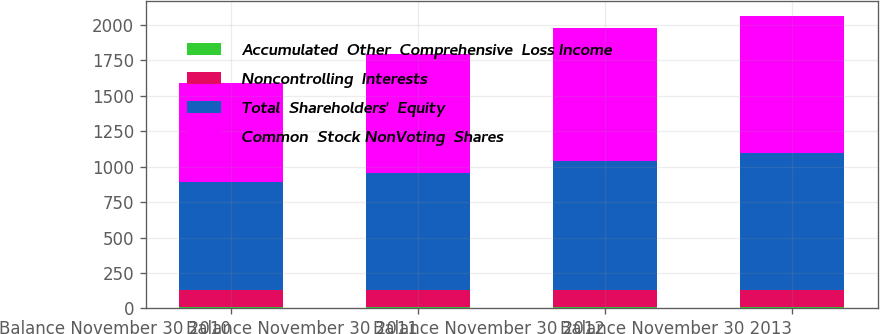<chart> <loc_0><loc_0><loc_500><loc_500><stacked_bar_chart><ecel><fcel>Balance November 30 2010<fcel>Balance November 30 2011<fcel>Balance November 30 2012<fcel>Balance November 30 2013<nl><fcel>Accumulated  Other  Comprehensive  Loss Income<fcel>12.5<fcel>12.4<fcel>12.4<fcel>12.1<nl><fcel>Noncontrolling  Interests<fcel>120.6<fcel>120.5<fcel>120.1<fcel>119<nl><fcel>Total  Shareholders'  Equity<fcel>756.5<fcel>821.9<fcel>908.2<fcel>962.4<nl><fcel>Common  Stock NonVoting  Shares<fcel>700.9<fcel>838.8<fcel>934.6<fcel>970.4<nl></chart> 